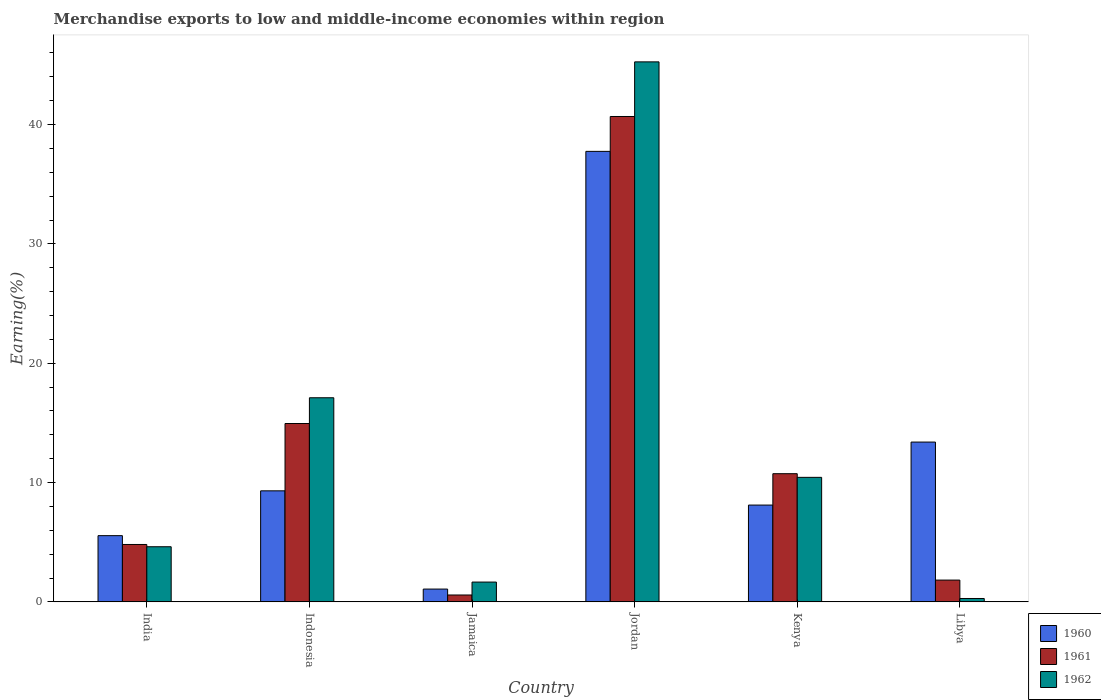How many different coloured bars are there?
Your answer should be compact. 3. How many bars are there on the 4th tick from the right?
Your answer should be very brief. 3. What is the label of the 2nd group of bars from the left?
Offer a terse response. Indonesia. In how many cases, is the number of bars for a given country not equal to the number of legend labels?
Give a very brief answer. 0. What is the percentage of amount earned from merchandise exports in 1961 in Jordan?
Make the answer very short. 40.68. Across all countries, what is the maximum percentage of amount earned from merchandise exports in 1961?
Provide a succinct answer. 40.68. Across all countries, what is the minimum percentage of amount earned from merchandise exports in 1962?
Keep it short and to the point. 0.28. In which country was the percentage of amount earned from merchandise exports in 1960 maximum?
Your answer should be very brief. Jordan. In which country was the percentage of amount earned from merchandise exports in 1961 minimum?
Provide a succinct answer. Jamaica. What is the total percentage of amount earned from merchandise exports in 1960 in the graph?
Your answer should be compact. 75.19. What is the difference between the percentage of amount earned from merchandise exports in 1960 in India and that in Kenya?
Offer a terse response. -2.56. What is the difference between the percentage of amount earned from merchandise exports in 1961 in India and the percentage of amount earned from merchandise exports in 1960 in Libya?
Make the answer very short. -8.58. What is the average percentage of amount earned from merchandise exports in 1961 per country?
Your response must be concise. 12.26. What is the difference between the percentage of amount earned from merchandise exports of/in 1962 and percentage of amount earned from merchandise exports of/in 1960 in Indonesia?
Ensure brevity in your answer.  7.8. In how many countries, is the percentage of amount earned from merchandise exports in 1960 greater than 44 %?
Your answer should be very brief. 0. What is the ratio of the percentage of amount earned from merchandise exports in 1960 in India to that in Libya?
Your answer should be compact. 0.41. What is the difference between the highest and the second highest percentage of amount earned from merchandise exports in 1961?
Your response must be concise. 29.94. What is the difference between the highest and the lowest percentage of amount earned from merchandise exports in 1960?
Your response must be concise. 36.68. What does the 3rd bar from the left in Kenya represents?
Your answer should be very brief. 1962. What does the 1st bar from the right in Jamaica represents?
Keep it short and to the point. 1962. Is it the case that in every country, the sum of the percentage of amount earned from merchandise exports in 1961 and percentage of amount earned from merchandise exports in 1960 is greater than the percentage of amount earned from merchandise exports in 1962?
Give a very brief answer. No. What is the difference between two consecutive major ticks on the Y-axis?
Provide a short and direct response. 10. Are the values on the major ticks of Y-axis written in scientific E-notation?
Keep it short and to the point. No. Does the graph contain grids?
Give a very brief answer. No. What is the title of the graph?
Offer a very short reply. Merchandise exports to low and middle-income economies within region. What is the label or title of the Y-axis?
Provide a succinct answer. Earning(%). What is the Earning(%) of 1960 in India?
Provide a succinct answer. 5.55. What is the Earning(%) in 1961 in India?
Provide a short and direct response. 4.81. What is the Earning(%) in 1962 in India?
Provide a succinct answer. 4.62. What is the Earning(%) of 1960 in Indonesia?
Offer a terse response. 9.31. What is the Earning(%) of 1961 in Indonesia?
Your answer should be compact. 14.95. What is the Earning(%) of 1962 in Indonesia?
Give a very brief answer. 17.11. What is the Earning(%) of 1960 in Jamaica?
Make the answer very short. 1.07. What is the Earning(%) in 1961 in Jamaica?
Your answer should be very brief. 0.58. What is the Earning(%) in 1962 in Jamaica?
Give a very brief answer. 1.66. What is the Earning(%) in 1960 in Jordan?
Provide a succinct answer. 37.76. What is the Earning(%) in 1961 in Jordan?
Offer a very short reply. 40.68. What is the Earning(%) of 1962 in Jordan?
Your answer should be very brief. 45.26. What is the Earning(%) in 1960 in Kenya?
Provide a short and direct response. 8.11. What is the Earning(%) in 1961 in Kenya?
Offer a very short reply. 10.74. What is the Earning(%) of 1962 in Kenya?
Provide a succinct answer. 10.44. What is the Earning(%) in 1960 in Libya?
Offer a very short reply. 13.39. What is the Earning(%) in 1961 in Libya?
Provide a short and direct response. 1.83. What is the Earning(%) of 1962 in Libya?
Provide a succinct answer. 0.28. Across all countries, what is the maximum Earning(%) in 1960?
Offer a terse response. 37.76. Across all countries, what is the maximum Earning(%) in 1961?
Provide a succinct answer. 40.68. Across all countries, what is the maximum Earning(%) in 1962?
Keep it short and to the point. 45.26. Across all countries, what is the minimum Earning(%) of 1960?
Offer a very short reply. 1.07. Across all countries, what is the minimum Earning(%) in 1961?
Your answer should be compact. 0.58. Across all countries, what is the minimum Earning(%) of 1962?
Offer a very short reply. 0.28. What is the total Earning(%) of 1960 in the graph?
Your answer should be very brief. 75.19. What is the total Earning(%) in 1961 in the graph?
Your answer should be compact. 73.58. What is the total Earning(%) in 1962 in the graph?
Provide a short and direct response. 79.36. What is the difference between the Earning(%) in 1960 in India and that in Indonesia?
Offer a terse response. -3.76. What is the difference between the Earning(%) in 1961 in India and that in Indonesia?
Your answer should be compact. -10.14. What is the difference between the Earning(%) of 1962 in India and that in Indonesia?
Provide a short and direct response. -12.49. What is the difference between the Earning(%) in 1960 in India and that in Jamaica?
Provide a short and direct response. 4.48. What is the difference between the Earning(%) of 1961 in India and that in Jamaica?
Your answer should be compact. 4.23. What is the difference between the Earning(%) of 1962 in India and that in Jamaica?
Ensure brevity in your answer.  2.96. What is the difference between the Earning(%) of 1960 in India and that in Jordan?
Your response must be concise. -32.2. What is the difference between the Earning(%) of 1961 in India and that in Jordan?
Offer a terse response. -35.87. What is the difference between the Earning(%) of 1962 in India and that in Jordan?
Provide a succinct answer. -40.64. What is the difference between the Earning(%) of 1960 in India and that in Kenya?
Offer a terse response. -2.56. What is the difference between the Earning(%) in 1961 in India and that in Kenya?
Your response must be concise. -5.93. What is the difference between the Earning(%) of 1962 in India and that in Kenya?
Your answer should be very brief. -5.82. What is the difference between the Earning(%) of 1960 in India and that in Libya?
Your answer should be very brief. -7.84. What is the difference between the Earning(%) in 1961 in India and that in Libya?
Ensure brevity in your answer.  2.98. What is the difference between the Earning(%) in 1962 in India and that in Libya?
Keep it short and to the point. 4.34. What is the difference between the Earning(%) in 1960 in Indonesia and that in Jamaica?
Give a very brief answer. 8.23. What is the difference between the Earning(%) of 1961 in Indonesia and that in Jamaica?
Give a very brief answer. 14.37. What is the difference between the Earning(%) in 1962 in Indonesia and that in Jamaica?
Provide a succinct answer. 15.45. What is the difference between the Earning(%) of 1960 in Indonesia and that in Jordan?
Make the answer very short. -28.45. What is the difference between the Earning(%) of 1961 in Indonesia and that in Jordan?
Give a very brief answer. -25.73. What is the difference between the Earning(%) of 1962 in Indonesia and that in Jordan?
Make the answer very short. -28.15. What is the difference between the Earning(%) of 1960 in Indonesia and that in Kenya?
Your answer should be compact. 1.19. What is the difference between the Earning(%) of 1961 in Indonesia and that in Kenya?
Your response must be concise. 4.21. What is the difference between the Earning(%) in 1962 in Indonesia and that in Kenya?
Your answer should be very brief. 6.67. What is the difference between the Earning(%) of 1960 in Indonesia and that in Libya?
Ensure brevity in your answer.  -4.09. What is the difference between the Earning(%) in 1961 in Indonesia and that in Libya?
Make the answer very short. 13.12. What is the difference between the Earning(%) of 1962 in Indonesia and that in Libya?
Make the answer very short. 16.82. What is the difference between the Earning(%) of 1960 in Jamaica and that in Jordan?
Your answer should be compact. -36.68. What is the difference between the Earning(%) in 1961 in Jamaica and that in Jordan?
Provide a short and direct response. -40.1. What is the difference between the Earning(%) of 1962 in Jamaica and that in Jordan?
Ensure brevity in your answer.  -43.6. What is the difference between the Earning(%) of 1960 in Jamaica and that in Kenya?
Your response must be concise. -7.04. What is the difference between the Earning(%) of 1961 in Jamaica and that in Kenya?
Provide a succinct answer. -10.17. What is the difference between the Earning(%) of 1962 in Jamaica and that in Kenya?
Your answer should be very brief. -8.78. What is the difference between the Earning(%) in 1960 in Jamaica and that in Libya?
Your answer should be compact. -12.32. What is the difference between the Earning(%) in 1961 in Jamaica and that in Libya?
Keep it short and to the point. -1.25. What is the difference between the Earning(%) in 1962 in Jamaica and that in Libya?
Provide a succinct answer. 1.38. What is the difference between the Earning(%) of 1960 in Jordan and that in Kenya?
Offer a terse response. 29.64. What is the difference between the Earning(%) in 1961 in Jordan and that in Kenya?
Your response must be concise. 29.94. What is the difference between the Earning(%) in 1962 in Jordan and that in Kenya?
Your response must be concise. 34.82. What is the difference between the Earning(%) of 1960 in Jordan and that in Libya?
Ensure brevity in your answer.  24.36. What is the difference between the Earning(%) in 1961 in Jordan and that in Libya?
Your answer should be very brief. 38.85. What is the difference between the Earning(%) of 1962 in Jordan and that in Libya?
Make the answer very short. 44.97. What is the difference between the Earning(%) in 1960 in Kenya and that in Libya?
Your answer should be compact. -5.28. What is the difference between the Earning(%) in 1961 in Kenya and that in Libya?
Give a very brief answer. 8.92. What is the difference between the Earning(%) of 1962 in Kenya and that in Libya?
Provide a succinct answer. 10.15. What is the difference between the Earning(%) in 1960 in India and the Earning(%) in 1961 in Indonesia?
Offer a terse response. -9.4. What is the difference between the Earning(%) in 1960 in India and the Earning(%) in 1962 in Indonesia?
Keep it short and to the point. -11.56. What is the difference between the Earning(%) in 1961 in India and the Earning(%) in 1962 in Indonesia?
Ensure brevity in your answer.  -12.3. What is the difference between the Earning(%) in 1960 in India and the Earning(%) in 1961 in Jamaica?
Ensure brevity in your answer.  4.97. What is the difference between the Earning(%) in 1960 in India and the Earning(%) in 1962 in Jamaica?
Offer a very short reply. 3.89. What is the difference between the Earning(%) in 1961 in India and the Earning(%) in 1962 in Jamaica?
Provide a short and direct response. 3.15. What is the difference between the Earning(%) of 1960 in India and the Earning(%) of 1961 in Jordan?
Your response must be concise. -35.13. What is the difference between the Earning(%) of 1960 in India and the Earning(%) of 1962 in Jordan?
Provide a short and direct response. -39.71. What is the difference between the Earning(%) of 1961 in India and the Earning(%) of 1962 in Jordan?
Keep it short and to the point. -40.45. What is the difference between the Earning(%) in 1960 in India and the Earning(%) in 1961 in Kenya?
Provide a succinct answer. -5.19. What is the difference between the Earning(%) in 1960 in India and the Earning(%) in 1962 in Kenya?
Your answer should be compact. -4.89. What is the difference between the Earning(%) of 1961 in India and the Earning(%) of 1962 in Kenya?
Offer a very short reply. -5.62. What is the difference between the Earning(%) in 1960 in India and the Earning(%) in 1961 in Libya?
Provide a short and direct response. 3.72. What is the difference between the Earning(%) of 1960 in India and the Earning(%) of 1962 in Libya?
Keep it short and to the point. 5.27. What is the difference between the Earning(%) of 1961 in India and the Earning(%) of 1962 in Libya?
Offer a very short reply. 4.53. What is the difference between the Earning(%) of 1960 in Indonesia and the Earning(%) of 1961 in Jamaica?
Provide a short and direct response. 8.73. What is the difference between the Earning(%) of 1960 in Indonesia and the Earning(%) of 1962 in Jamaica?
Provide a short and direct response. 7.65. What is the difference between the Earning(%) in 1961 in Indonesia and the Earning(%) in 1962 in Jamaica?
Ensure brevity in your answer.  13.29. What is the difference between the Earning(%) in 1960 in Indonesia and the Earning(%) in 1961 in Jordan?
Provide a short and direct response. -31.37. What is the difference between the Earning(%) in 1960 in Indonesia and the Earning(%) in 1962 in Jordan?
Give a very brief answer. -35.95. What is the difference between the Earning(%) of 1961 in Indonesia and the Earning(%) of 1962 in Jordan?
Offer a very short reply. -30.31. What is the difference between the Earning(%) in 1960 in Indonesia and the Earning(%) in 1961 in Kenya?
Offer a terse response. -1.44. What is the difference between the Earning(%) in 1960 in Indonesia and the Earning(%) in 1962 in Kenya?
Give a very brief answer. -1.13. What is the difference between the Earning(%) in 1961 in Indonesia and the Earning(%) in 1962 in Kenya?
Provide a short and direct response. 4.51. What is the difference between the Earning(%) of 1960 in Indonesia and the Earning(%) of 1961 in Libya?
Make the answer very short. 7.48. What is the difference between the Earning(%) in 1960 in Indonesia and the Earning(%) in 1962 in Libya?
Provide a short and direct response. 9.02. What is the difference between the Earning(%) of 1961 in Indonesia and the Earning(%) of 1962 in Libya?
Provide a succinct answer. 14.66. What is the difference between the Earning(%) in 1960 in Jamaica and the Earning(%) in 1961 in Jordan?
Provide a short and direct response. -39.6. What is the difference between the Earning(%) of 1960 in Jamaica and the Earning(%) of 1962 in Jordan?
Keep it short and to the point. -44.18. What is the difference between the Earning(%) of 1961 in Jamaica and the Earning(%) of 1962 in Jordan?
Make the answer very short. -44.68. What is the difference between the Earning(%) in 1960 in Jamaica and the Earning(%) in 1961 in Kenya?
Your answer should be compact. -9.67. What is the difference between the Earning(%) in 1960 in Jamaica and the Earning(%) in 1962 in Kenya?
Provide a short and direct response. -9.36. What is the difference between the Earning(%) in 1961 in Jamaica and the Earning(%) in 1962 in Kenya?
Provide a short and direct response. -9.86. What is the difference between the Earning(%) of 1960 in Jamaica and the Earning(%) of 1961 in Libya?
Keep it short and to the point. -0.75. What is the difference between the Earning(%) of 1960 in Jamaica and the Earning(%) of 1962 in Libya?
Provide a succinct answer. 0.79. What is the difference between the Earning(%) in 1961 in Jamaica and the Earning(%) in 1962 in Libya?
Ensure brevity in your answer.  0.29. What is the difference between the Earning(%) of 1960 in Jordan and the Earning(%) of 1961 in Kenya?
Offer a terse response. 27.01. What is the difference between the Earning(%) in 1960 in Jordan and the Earning(%) in 1962 in Kenya?
Your answer should be very brief. 27.32. What is the difference between the Earning(%) of 1961 in Jordan and the Earning(%) of 1962 in Kenya?
Offer a very short reply. 30.24. What is the difference between the Earning(%) of 1960 in Jordan and the Earning(%) of 1961 in Libya?
Give a very brief answer. 35.93. What is the difference between the Earning(%) of 1960 in Jordan and the Earning(%) of 1962 in Libya?
Keep it short and to the point. 37.47. What is the difference between the Earning(%) in 1961 in Jordan and the Earning(%) in 1962 in Libya?
Ensure brevity in your answer.  40.39. What is the difference between the Earning(%) in 1960 in Kenya and the Earning(%) in 1961 in Libya?
Provide a short and direct response. 6.29. What is the difference between the Earning(%) in 1960 in Kenya and the Earning(%) in 1962 in Libya?
Offer a very short reply. 7.83. What is the difference between the Earning(%) in 1961 in Kenya and the Earning(%) in 1962 in Libya?
Provide a succinct answer. 10.46. What is the average Earning(%) of 1960 per country?
Keep it short and to the point. 12.53. What is the average Earning(%) of 1961 per country?
Provide a succinct answer. 12.26. What is the average Earning(%) in 1962 per country?
Your answer should be very brief. 13.23. What is the difference between the Earning(%) in 1960 and Earning(%) in 1961 in India?
Your answer should be compact. 0.74. What is the difference between the Earning(%) of 1960 and Earning(%) of 1962 in India?
Provide a succinct answer. 0.93. What is the difference between the Earning(%) in 1961 and Earning(%) in 1962 in India?
Offer a very short reply. 0.19. What is the difference between the Earning(%) in 1960 and Earning(%) in 1961 in Indonesia?
Make the answer very short. -5.64. What is the difference between the Earning(%) in 1960 and Earning(%) in 1962 in Indonesia?
Make the answer very short. -7.8. What is the difference between the Earning(%) of 1961 and Earning(%) of 1962 in Indonesia?
Your response must be concise. -2.16. What is the difference between the Earning(%) in 1960 and Earning(%) in 1961 in Jamaica?
Your answer should be compact. 0.5. What is the difference between the Earning(%) of 1960 and Earning(%) of 1962 in Jamaica?
Your answer should be compact. -0.59. What is the difference between the Earning(%) of 1961 and Earning(%) of 1962 in Jamaica?
Give a very brief answer. -1.08. What is the difference between the Earning(%) in 1960 and Earning(%) in 1961 in Jordan?
Provide a succinct answer. -2.92. What is the difference between the Earning(%) in 1960 and Earning(%) in 1962 in Jordan?
Your response must be concise. -7.5. What is the difference between the Earning(%) in 1961 and Earning(%) in 1962 in Jordan?
Make the answer very short. -4.58. What is the difference between the Earning(%) in 1960 and Earning(%) in 1961 in Kenya?
Offer a very short reply. -2.63. What is the difference between the Earning(%) of 1960 and Earning(%) of 1962 in Kenya?
Provide a short and direct response. -2.32. What is the difference between the Earning(%) in 1961 and Earning(%) in 1962 in Kenya?
Your answer should be compact. 0.31. What is the difference between the Earning(%) of 1960 and Earning(%) of 1961 in Libya?
Give a very brief answer. 11.57. What is the difference between the Earning(%) in 1960 and Earning(%) in 1962 in Libya?
Provide a short and direct response. 13.11. What is the difference between the Earning(%) of 1961 and Earning(%) of 1962 in Libya?
Offer a terse response. 1.54. What is the ratio of the Earning(%) of 1960 in India to that in Indonesia?
Ensure brevity in your answer.  0.6. What is the ratio of the Earning(%) of 1961 in India to that in Indonesia?
Give a very brief answer. 0.32. What is the ratio of the Earning(%) of 1962 in India to that in Indonesia?
Offer a very short reply. 0.27. What is the ratio of the Earning(%) of 1960 in India to that in Jamaica?
Offer a terse response. 5.17. What is the ratio of the Earning(%) in 1961 in India to that in Jamaica?
Offer a terse response. 8.34. What is the ratio of the Earning(%) of 1962 in India to that in Jamaica?
Make the answer very short. 2.78. What is the ratio of the Earning(%) in 1960 in India to that in Jordan?
Provide a short and direct response. 0.15. What is the ratio of the Earning(%) of 1961 in India to that in Jordan?
Your answer should be very brief. 0.12. What is the ratio of the Earning(%) in 1962 in India to that in Jordan?
Your response must be concise. 0.1. What is the ratio of the Earning(%) in 1960 in India to that in Kenya?
Your answer should be compact. 0.68. What is the ratio of the Earning(%) of 1961 in India to that in Kenya?
Offer a terse response. 0.45. What is the ratio of the Earning(%) in 1962 in India to that in Kenya?
Your response must be concise. 0.44. What is the ratio of the Earning(%) in 1960 in India to that in Libya?
Your answer should be compact. 0.41. What is the ratio of the Earning(%) of 1961 in India to that in Libya?
Make the answer very short. 2.63. What is the ratio of the Earning(%) of 1962 in India to that in Libya?
Provide a short and direct response. 16.3. What is the ratio of the Earning(%) in 1960 in Indonesia to that in Jamaica?
Ensure brevity in your answer.  8.67. What is the ratio of the Earning(%) of 1961 in Indonesia to that in Jamaica?
Your response must be concise. 25.91. What is the ratio of the Earning(%) of 1962 in Indonesia to that in Jamaica?
Your answer should be compact. 10.3. What is the ratio of the Earning(%) in 1960 in Indonesia to that in Jordan?
Your response must be concise. 0.25. What is the ratio of the Earning(%) in 1961 in Indonesia to that in Jordan?
Keep it short and to the point. 0.37. What is the ratio of the Earning(%) in 1962 in Indonesia to that in Jordan?
Your response must be concise. 0.38. What is the ratio of the Earning(%) of 1960 in Indonesia to that in Kenya?
Make the answer very short. 1.15. What is the ratio of the Earning(%) in 1961 in Indonesia to that in Kenya?
Your answer should be compact. 1.39. What is the ratio of the Earning(%) of 1962 in Indonesia to that in Kenya?
Your response must be concise. 1.64. What is the ratio of the Earning(%) of 1960 in Indonesia to that in Libya?
Your answer should be very brief. 0.69. What is the ratio of the Earning(%) in 1961 in Indonesia to that in Libya?
Keep it short and to the point. 8.18. What is the ratio of the Earning(%) in 1962 in Indonesia to that in Libya?
Offer a very short reply. 60.34. What is the ratio of the Earning(%) of 1960 in Jamaica to that in Jordan?
Make the answer very short. 0.03. What is the ratio of the Earning(%) in 1961 in Jamaica to that in Jordan?
Offer a very short reply. 0.01. What is the ratio of the Earning(%) in 1962 in Jamaica to that in Jordan?
Your answer should be compact. 0.04. What is the ratio of the Earning(%) of 1960 in Jamaica to that in Kenya?
Offer a terse response. 0.13. What is the ratio of the Earning(%) in 1961 in Jamaica to that in Kenya?
Provide a succinct answer. 0.05. What is the ratio of the Earning(%) of 1962 in Jamaica to that in Kenya?
Ensure brevity in your answer.  0.16. What is the ratio of the Earning(%) of 1960 in Jamaica to that in Libya?
Keep it short and to the point. 0.08. What is the ratio of the Earning(%) of 1961 in Jamaica to that in Libya?
Your response must be concise. 0.32. What is the ratio of the Earning(%) of 1962 in Jamaica to that in Libya?
Give a very brief answer. 5.86. What is the ratio of the Earning(%) of 1960 in Jordan to that in Kenya?
Keep it short and to the point. 4.65. What is the ratio of the Earning(%) in 1961 in Jordan to that in Kenya?
Provide a short and direct response. 3.79. What is the ratio of the Earning(%) in 1962 in Jordan to that in Kenya?
Ensure brevity in your answer.  4.34. What is the ratio of the Earning(%) of 1960 in Jordan to that in Libya?
Keep it short and to the point. 2.82. What is the ratio of the Earning(%) of 1961 in Jordan to that in Libya?
Your response must be concise. 22.27. What is the ratio of the Earning(%) of 1962 in Jordan to that in Libya?
Ensure brevity in your answer.  159.64. What is the ratio of the Earning(%) in 1960 in Kenya to that in Libya?
Provide a succinct answer. 0.61. What is the ratio of the Earning(%) of 1961 in Kenya to that in Libya?
Provide a succinct answer. 5.88. What is the ratio of the Earning(%) of 1962 in Kenya to that in Libya?
Provide a succinct answer. 36.81. What is the difference between the highest and the second highest Earning(%) in 1960?
Your response must be concise. 24.36. What is the difference between the highest and the second highest Earning(%) of 1961?
Ensure brevity in your answer.  25.73. What is the difference between the highest and the second highest Earning(%) in 1962?
Keep it short and to the point. 28.15. What is the difference between the highest and the lowest Earning(%) in 1960?
Offer a terse response. 36.68. What is the difference between the highest and the lowest Earning(%) of 1961?
Offer a very short reply. 40.1. What is the difference between the highest and the lowest Earning(%) in 1962?
Offer a terse response. 44.97. 